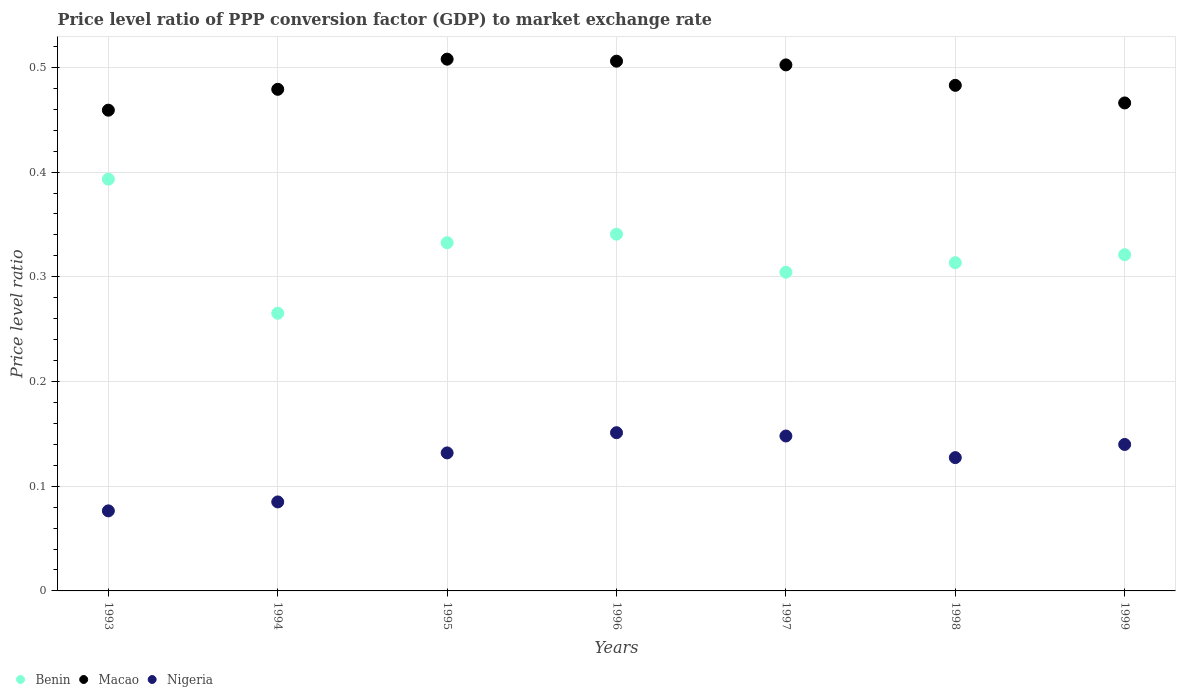What is the price level ratio in Macao in 1994?
Offer a terse response. 0.48. Across all years, what is the maximum price level ratio in Benin?
Ensure brevity in your answer.  0.39. Across all years, what is the minimum price level ratio in Benin?
Make the answer very short. 0.27. In which year was the price level ratio in Macao minimum?
Provide a short and direct response. 1993. What is the total price level ratio in Nigeria in the graph?
Offer a very short reply. 0.86. What is the difference between the price level ratio in Benin in 1996 and that in 1998?
Your response must be concise. 0.03. What is the difference between the price level ratio in Macao in 1993 and the price level ratio in Benin in 1994?
Offer a very short reply. 0.19. What is the average price level ratio in Nigeria per year?
Make the answer very short. 0.12. In the year 1995, what is the difference between the price level ratio in Macao and price level ratio in Benin?
Ensure brevity in your answer.  0.18. In how many years, is the price level ratio in Nigeria greater than 0.36000000000000004?
Give a very brief answer. 0. What is the ratio of the price level ratio in Nigeria in 1995 to that in 1997?
Offer a very short reply. 0.89. Is the price level ratio in Macao in 1993 less than that in 1998?
Give a very brief answer. Yes. What is the difference between the highest and the second highest price level ratio in Benin?
Your response must be concise. 0.05. What is the difference between the highest and the lowest price level ratio in Benin?
Make the answer very short. 0.13. Does the price level ratio in Benin monotonically increase over the years?
Keep it short and to the point. No. Is the price level ratio in Benin strictly greater than the price level ratio in Macao over the years?
Your answer should be very brief. No. How many dotlines are there?
Offer a very short reply. 3. How many legend labels are there?
Ensure brevity in your answer.  3. What is the title of the graph?
Ensure brevity in your answer.  Price level ratio of PPP conversion factor (GDP) to market exchange rate. Does "Mauritius" appear as one of the legend labels in the graph?
Your response must be concise. No. What is the label or title of the Y-axis?
Your answer should be compact. Price level ratio. What is the Price level ratio in Benin in 1993?
Ensure brevity in your answer.  0.39. What is the Price level ratio in Macao in 1993?
Offer a very short reply. 0.46. What is the Price level ratio of Nigeria in 1993?
Your answer should be very brief. 0.08. What is the Price level ratio of Benin in 1994?
Give a very brief answer. 0.27. What is the Price level ratio of Macao in 1994?
Your answer should be very brief. 0.48. What is the Price level ratio in Nigeria in 1994?
Your answer should be very brief. 0.08. What is the Price level ratio of Benin in 1995?
Provide a short and direct response. 0.33. What is the Price level ratio of Macao in 1995?
Provide a short and direct response. 0.51. What is the Price level ratio in Nigeria in 1995?
Your answer should be very brief. 0.13. What is the Price level ratio in Benin in 1996?
Make the answer very short. 0.34. What is the Price level ratio of Macao in 1996?
Provide a short and direct response. 0.51. What is the Price level ratio of Nigeria in 1996?
Make the answer very short. 0.15. What is the Price level ratio in Benin in 1997?
Keep it short and to the point. 0.3. What is the Price level ratio of Macao in 1997?
Provide a succinct answer. 0.5. What is the Price level ratio of Nigeria in 1997?
Provide a short and direct response. 0.15. What is the Price level ratio of Benin in 1998?
Provide a short and direct response. 0.31. What is the Price level ratio in Macao in 1998?
Offer a very short reply. 0.48. What is the Price level ratio of Nigeria in 1998?
Provide a succinct answer. 0.13. What is the Price level ratio in Benin in 1999?
Provide a succinct answer. 0.32. What is the Price level ratio of Macao in 1999?
Offer a terse response. 0.47. What is the Price level ratio in Nigeria in 1999?
Make the answer very short. 0.14. Across all years, what is the maximum Price level ratio of Benin?
Your response must be concise. 0.39. Across all years, what is the maximum Price level ratio in Macao?
Offer a terse response. 0.51. Across all years, what is the maximum Price level ratio of Nigeria?
Give a very brief answer. 0.15. Across all years, what is the minimum Price level ratio of Benin?
Your answer should be compact. 0.27. Across all years, what is the minimum Price level ratio in Macao?
Offer a terse response. 0.46. Across all years, what is the minimum Price level ratio of Nigeria?
Provide a short and direct response. 0.08. What is the total Price level ratio of Benin in the graph?
Give a very brief answer. 2.27. What is the total Price level ratio of Macao in the graph?
Your answer should be compact. 3.4. What is the total Price level ratio in Nigeria in the graph?
Your answer should be compact. 0.86. What is the difference between the Price level ratio of Benin in 1993 and that in 1994?
Your answer should be very brief. 0.13. What is the difference between the Price level ratio in Macao in 1993 and that in 1994?
Your answer should be compact. -0.02. What is the difference between the Price level ratio in Nigeria in 1993 and that in 1994?
Keep it short and to the point. -0.01. What is the difference between the Price level ratio of Benin in 1993 and that in 1995?
Make the answer very short. 0.06. What is the difference between the Price level ratio in Macao in 1993 and that in 1995?
Your answer should be compact. -0.05. What is the difference between the Price level ratio of Nigeria in 1993 and that in 1995?
Ensure brevity in your answer.  -0.06. What is the difference between the Price level ratio in Benin in 1993 and that in 1996?
Give a very brief answer. 0.05. What is the difference between the Price level ratio in Macao in 1993 and that in 1996?
Ensure brevity in your answer.  -0.05. What is the difference between the Price level ratio in Nigeria in 1993 and that in 1996?
Provide a short and direct response. -0.07. What is the difference between the Price level ratio in Benin in 1993 and that in 1997?
Your answer should be compact. 0.09. What is the difference between the Price level ratio in Macao in 1993 and that in 1997?
Ensure brevity in your answer.  -0.04. What is the difference between the Price level ratio of Nigeria in 1993 and that in 1997?
Your answer should be very brief. -0.07. What is the difference between the Price level ratio in Benin in 1993 and that in 1998?
Provide a short and direct response. 0.08. What is the difference between the Price level ratio of Macao in 1993 and that in 1998?
Your response must be concise. -0.02. What is the difference between the Price level ratio in Nigeria in 1993 and that in 1998?
Offer a terse response. -0.05. What is the difference between the Price level ratio in Benin in 1993 and that in 1999?
Your response must be concise. 0.07. What is the difference between the Price level ratio in Macao in 1993 and that in 1999?
Your answer should be very brief. -0.01. What is the difference between the Price level ratio in Nigeria in 1993 and that in 1999?
Make the answer very short. -0.06. What is the difference between the Price level ratio of Benin in 1994 and that in 1995?
Provide a short and direct response. -0.07. What is the difference between the Price level ratio of Macao in 1994 and that in 1995?
Offer a very short reply. -0.03. What is the difference between the Price level ratio of Nigeria in 1994 and that in 1995?
Offer a very short reply. -0.05. What is the difference between the Price level ratio of Benin in 1994 and that in 1996?
Provide a short and direct response. -0.08. What is the difference between the Price level ratio of Macao in 1994 and that in 1996?
Ensure brevity in your answer.  -0.03. What is the difference between the Price level ratio in Nigeria in 1994 and that in 1996?
Make the answer very short. -0.07. What is the difference between the Price level ratio of Benin in 1994 and that in 1997?
Your response must be concise. -0.04. What is the difference between the Price level ratio of Macao in 1994 and that in 1997?
Ensure brevity in your answer.  -0.02. What is the difference between the Price level ratio in Nigeria in 1994 and that in 1997?
Give a very brief answer. -0.06. What is the difference between the Price level ratio in Benin in 1994 and that in 1998?
Provide a succinct answer. -0.05. What is the difference between the Price level ratio in Macao in 1994 and that in 1998?
Your answer should be very brief. -0. What is the difference between the Price level ratio in Nigeria in 1994 and that in 1998?
Your response must be concise. -0.04. What is the difference between the Price level ratio of Benin in 1994 and that in 1999?
Offer a terse response. -0.06. What is the difference between the Price level ratio in Macao in 1994 and that in 1999?
Your response must be concise. 0.01. What is the difference between the Price level ratio of Nigeria in 1994 and that in 1999?
Offer a very short reply. -0.05. What is the difference between the Price level ratio in Benin in 1995 and that in 1996?
Your answer should be very brief. -0.01. What is the difference between the Price level ratio in Macao in 1995 and that in 1996?
Make the answer very short. 0. What is the difference between the Price level ratio in Nigeria in 1995 and that in 1996?
Your answer should be very brief. -0.02. What is the difference between the Price level ratio of Benin in 1995 and that in 1997?
Provide a succinct answer. 0.03. What is the difference between the Price level ratio of Macao in 1995 and that in 1997?
Provide a succinct answer. 0.01. What is the difference between the Price level ratio of Nigeria in 1995 and that in 1997?
Make the answer very short. -0.02. What is the difference between the Price level ratio in Benin in 1995 and that in 1998?
Provide a succinct answer. 0.02. What is the difference between the Price level ratio of Macao in 1995 and that in 1998?
Ensure brevity in your answer.  0.03. What is the difference between the Price level ratio in Nigeria in 1995 and that in 1998?
Provide a short and direct response. 0. What is the difference between the Price level ratio in Benin in 1995 and that in 1999?
Provide a short and direct response. 0.01. What is the difference between the Price level ratio in Macao in 1995 and that in 1999?
Ensure brevity in your answer.  0.04. What is the difference between the Price level ratio in Nigeria in 1995 and that in 1999?
Provide a succinct answer. -0.01. What is the difference between the Price level ratio of Benin in 1996 and that in 1997?
Your answer should be compact. 0.04. What is the difference between the Price level ratio in Macao in 1996 and that in 1997?
Keep it short and to the point. 0. What is the difference between the Price level ratio in Nigeria in 1996 and that in 1997?
Your answer should be very brief. 0. What is the difference between the Price level ratio of Benin in 1996 and that in 1998?
Offer a terse response. 0.03. What is the difference between the Price level ratio of Macao in 1996 and that in 1998?
Provide a succinct answer. 0.02. What is the difference between the Price level ratio in Nigeria in 1996 and that in 1998?
Provide a succinct answer. 0.02. What is the difference between the Price level ratio of Benin in 1996 and that in 1999?
Make the answer very short. 0.02. What is the difference between the Price level ratio of Macao in 1996 and that in 1999?
Make the answer very short. 0.04. What is the difference between the Price level ratio of Nigeria in 1996 and that in 1999?
Your answer should be compact. 0.01. What is the difference between the Price level ratio in Benin in 1997 and that in 1998?
Offer a terse response. -0.01. What is the difference between the Price level ratio of Macao in 1997 and that in 1998?
Make the answer very short. 0.02. What is the difference between the Price level ratio in Nigeria in 1997 and that in 1998?
Offer a terse response. 0.02. What is the difference between the Price level ratio in Benin in 1997 and that in 1999?
Your answer should be very brief. -0.02. What is the difference between the Price level ratio of Macao in 1997 and that in 1999?
Offer a very short reply. 0.04. What is the difference between the Price level ratio of Nigeria in 1997 and that in 1999?
Provide a short and direct response. 0.01. What is the difference between the Price level ratio in Benin in 1998 and that in 1999?
Provide a succinct answer. -0.01. What is the difference between the Price level ratio of Macao in 1998 and that in 1999?
Offer a very short reply. 0.02. What is the difference between the Price level ratio in Nigeria in 1998 and that in 1999?
Ensure brevity in your answer.  -0.01. What is the difference between the Price level ratio of Benin in 1993 and the Price level ratio of Macao in 1994?
Keep it short and to the point. -0.09. What is the difference between the Price level ratio in Benin in 1993 and the Price level ratio in Nigeria in 1994?
Your answer should be compact. 0.31. What is the difference between the Price level ratio of Macao in 1993 and the Price level ratio of Nigeria in 1994?
Make the answer very short. 0.37. What is the difference between the Price level ratio in Benin in 1993 and the Price level ratio in Macao in 1995?
Keep it short and to the point. -0.11. What is the difference between the Price level ratio in Benin in 1993 and the Price level ratio in Nigeria in 1995?
Provide a short and direct response. 0.26. What is the difference between the Price level ratio of Macao in 1993 and the Price level ratio of Nigeria in 1995?
Your answer should be very brief. 0.33. What is the difference between the Price level ratio of Benin in 1993 and the Price level ratio of Macao in 1996?
Ensure brevity in your answer.  -0.11. What is the difference between the Price level ratio of Benin in 1993 and the Price level ratio of Nigeria in 1996?
Make the answer very short. 0.24. What is the difference between the Price level ratio in Macao in 1993 and the Price level ratio in Nigeria in 1996?
Provide a short and direct response. 0.31. What is the difference between the Price level ratio in Benin in 1993 and the Price level ratio in Macao in 1997?
Your answer should be compact. -0.11. What is the difference between the Price level ratio in Benin in 1993 and the Price level ratio in Nigeria in 1997?
Your answer should be very brief. 0.25. What is the difference between the Price level ratio of Macao in 1993 and the Price level ratio of Nigeria in 1997?
Keep it short and to the point. 0.31. What is the difference between the Price level ratio of Benin in 1993 and the Price level ratio of Macao in 1998?
Offer a very short reply. -0.09. What is the difference between the Price level ratio in Benin in 1993 and the Price level ratio in Nigeria in 1998?
Offer a terse response. 0.27. What is the difference between the Price level ratio of Macao in 1993 and the Price level ratio of Nigeria in 1998?
Give a very brief answer. 0.33. What is the difference between the Price level ratio of Benin in 1993 and the Price level ratio of Macao in 1999?
Provide a succinct answer. -0.07. What is the difference between the Price level ratio of Benin in 1993 and the Price level ratio of Nigeria in 1999?
Provide a succinct answer. 0.25. What is the difference between the Price level ratio in Macao in 1993 and the Price level ratio in Nigeria in 1999?
Your answer should be compact. 0.32. What is the difference between the Price level ratio of Benin in 1994 and the Price level ratio of Macao in 1995?
Make the answer very short. -0.24. What is the difference between the Price level ratio of Benin in 1994 and the Price level ratio of Nigeria in 1995?
Offer a terse response. 0.13. What is the difference between the Price level ratio in Macao in 1994 and the Price level ratio in Nigeria in 1995?
Offer a very short reply. 0.35. What is the difference between the Price level ratio in Benin in 1994 and the Price level ratio in Macao in 1996?
Your answer should be very brief. -0.24. What is the difference between the Price level ratio in Benin in 1994 and the Price level ratio in Nigeria in 1996?
Keep it short and to the point. 0.11. What is the difference between the Price level ratio of Macao in 1994 and the Price level ratio of Nigeria in 1996?
Provide a short and direct response. 0.33. What is the difference between the Price level ratio of Benin in 1994 and the Price level ratio of Macao in 1997?
Offer a terse response. -0.24. What is the difference between the Price level ratio of Benin in 1994 and the Price level ratio of Nigeria in 1997?
Provide a succinct answer. 0.12. What is the difference between the Price level ratio of Macao in 1994 and the Price level ratio of Nigeria in 1997?
Offer a very short reply. 0.33. What is the difference between the Price level ratio of Benin in 1994 and the Price level ratio of Macao in 1998?
Your answer should be compact. -0.22. What is the difference between the Price level ratio in Benin in 1994 and the Price level ratio in Nigeria in 1998?
Keep it short and to the point. 0.14. What is the difference between the Price level ratio of Macao in 1994 and the Price level ratio of Nigeria in 1998?
Keep it short and to the point. 0.35. What is the difference between the Price level ratio of Benin in 1994 and the Price level ratio of Macao in 1999?
Provide a succinct answer. -0.2. What is the difference between the Price level ratio of Benin in 1994 and the Price level ratio of Nigeria in 1999?
Your answer should be compact. 0.13. What is the difference between the Price level ratio of Macao in 1994 and the Price level ratio of Nigeria in 1999?
Offer a very short reply. 0.34. What is the difference between the Price level ratio of Benin in 1995 and the Price level ratio of Macao in 1996?
Offer a very short reply. -0.17. What is the difference between the Price level ratio in Benin in 1995 and the Price level ratio in Nigeria in 1996?
Your answer should be very brief. 0.18. What is the difference between the Price level ratio in Macao in 1995 and the Price level ratio in Nigeria in 1996?
Ensure brevity in your answer.  0.36. What is the difference between the Price level ratio in Benin in 1995 and the Price level ratio in Macao in 1997?
Keep it short and to the point. -0.17. What is the difference between the Price level ratio in Benin in 1995 and the Price level ratio in Nigeria in 1997?
Give a very brief answer. 0.18. What is the difference between the Price level ratio in Macao in 1995 and the Price level ratio in Nigeria in 1997?
Make the answer very short. 0.36. What is the difference between the Price level ratio in Benin in 1995 and the Price level ratio in Macao in 1998?
Keep it short and to the point. -0.15. What is the difference between the Price level ratio of Benin in 1995 and the Price level ratio of Nigeria in 1998?
Give a very brief answer. 0.21. What is the difference between the Price level ratio in Macao in 1995 and the Price level ratio in Nigeria in 1998?
Ensure brevity in your answer.  0.38. What is the difference between the Price level ratio of Benin in 1995 and the Price level ratio of Macao in 1999?
Offer a terse response. -0.13. What is the difference between the Price level ratio of Benin in 1995 and the Price level ratio of Nigeria in 1999?
Offer a terse response. 0.19. What is the difference between the Price level ratio of Macao in 1995 and the Price level ratio of Nigeria in 1999?
Your answer should be compact. 0.37. What is the difference between the Price level ratio in Benin in 1996 and the Price level ratio in Macao in 1997?
Give a very brief answer. -0.16. What is the difference between the Price level ratio of Benin in 1996 and the Price level ratio of Nigeria in 1997?
Your response must be concise. 0.19. What is the difference between the Price level ratio in Macao in 1996 and the Price level ratio in Nigeria in 1997?
Provide a short and direct response. 0.36. What is the difference between the Price level ratio of Benin in 1996 and the Price level ratio of Macao in 1998?
Your answer should be compact. -0.14. What is the difference between the Price level ratio of Benin in 1996 and the Price level ratio of Nigeria in 1998?
Ensure brevity in your answer.  0.21. What is the difference between the Price level ratio in Macao in 1996 and the Price level ratio in Nigeria in 1998?
Provide a succinct answer. 0.38. What is the difference between the Price level ratio of Benin in 1996 and the Price level ratio of Macao in 1999?
Make the answer very short. -0.13. What is the difference between the Price level ratio of Benin in 1996 and the Price level ratio of Nigeria in 1999?
Make the answer very short. 0.2. What is the difference between the Price level ratio of Macao in 1996 and the Price level ratio of Nigeria in 1999?
Offer a terse response. 0.37. What is the difference between the Price level ratio of Benin in 1997 and the Price level ratio of Macao in 1998?
Keep it short and to the point. -0.18. What is the difference between the Price level ratio of Benin in 1997 and the Price level ratio of Nigeria in 1998?
Your answer should be compact. 0.18. What is the difference between the Price level ratio of Macao in 1997 and the Price level ratio of Nigeria in 1998?
Provide a short and direct response. 0.38. What is the difference between the Price level ratio in Benin in 1997 and the Price level ratio in Macao in 1999?
Offer a very short reply. -0.16. What is the difference between the Price level ratio of Benin in 1997 and the Price level ratio of Nigeria in 1999?
Ensure brevity in your answer.  0.16. What is the difference between the Price level ratio in Macao in 1997 and the Price level ratio in Nigeria in 1999?
Give a very brief answer. 0.36. What is the difference between the Price level ratio of Benin in 1998 and the Price level ratio of Macao in 1999?
Ensure brevity in your answer.  -0.15. What is the difference between the Price level ratio of Benin in 1998 and the Price level ratio of Nigeria in 1999?
Ensure brevity in your answer.  0.17. What is the difference between the Price level ratio in Macao in 1998 and the Price level ratio in Nigeria in 1999?
Give a very brief answer. 0.34. What is the average Price level ratio in Benin per year?
Provide a succinct answer. 0.32. What is the average Price level ratio in Macao per year?
Provide a short and direct response. 0.49. What is the average Price level ratio of Nigeria per year?
Your answer should be very brief. 0.12. In the year 1993, what is the difference between the Price level ratio of Benin and Price level ratio of Macao?
Your answer should be compact. -0.07. In the year 1993, what is the difference between the Price level ratio of Benin and Price level ratio of Nigeria?
Your answer should be compact. 0.32. In the year 1993, what is the difference between the Price level ratio in Macao and Price level ratio in Nigeria?
Give a very brief answer. 0.38. In the year 1994, what is the difference between the Price level ratio in Benin and Price level ratio in Macao?
Offer a very short reply. -0.21. In the year 1994, what is the difference between the Price level ratio in Benin and Price level ratio in Nigeria?
Ensure brevity in your answer.  0.18. In the year 1994, what is the difference between the Price level ratio of Macao and Price level ratio of Nigeria?
Give a very brief answer. 0.39. In the year 1995, what is the difference between the Price level ratio in Benin and Price level ratio in Macao?
Offer a very short reply. -0.18. In the year 1995, what is the difference between the Price level ratio in Benin and Price level ratio in Nigeria?
Your answer should be compact. 0.2. In the year 1995, what is the difference between the Price level ratio of Macao and Price level ratio of Nigeria?
Offer a very short reply. 0.38. In the year 1996, what is the difference between the Price level ratio of Benin and Price level ratio of Macao?
Provide a succinct answer. -0.17. In the year 1996, what is the difference between the Price level ratio of Benin and Price level ratio of Nigeria?
Give a very brief answer. 0.19. In the year 1996, what is the difference between the Price level ratio in Macao and Price level ratio in Nigeria?
Keep it short and to the point. 0.35. In the year 1997, what is the difference between the Price level ratio of Benin and Price level ratio of Macao?
Offer a terse response. -0.2. In the year 1997, what is the difference between the Price level ratio of Benin and Price level ratio of Nigeria?
Make the answer very short. 0.16. In the year 1997, what is the difference between the Price level ratio of Macao and Price level ratio of Nigeria?
Offer a terse response. 0.35. In the year 1998, what is the difference between the Price level ratio of Benin and Price level ratio of Macao?
Ensure brevity in your answer.  -0.17. In the year 1998, what is the difference between the Price level ratio of Benin and Price level ratio of Nigeria?
Provide a short and direct response. 0.19. In the year 1998, what is the difference between the Price level ratio of Macao and Price level ratio of Nigeria?
Ensure brevity in your answer.  0.36. In the year 1999, what is the difference between the Price level ratio of Benin and Price level ratio of Macao?
Your answer should be compact. -0.14. In the year 1999, what is the difference between the Price level ratio in Benin and Price level ratio in Nigeria?
Offer a very short reply. 0.18. In the year 1999, what is the difference between the Price level ratio of Macao and Price level ratio of Nigeria?
Your response must be concise. 0.33. What is the ratio of the Price level ratio in Benin in 1993 to that in 1994?
Ensure brevity in your answer.  1.48. What is the ratio of the Price level ratio in Macao in 1993 to that in 1994?
Ensure brevity in your answer.  0.96. What is the ratio of the Price level ratio of Nigeria in 1993 to that in 1994?
Ensure brevity in your answer.  0.9. What is the ratio of the Price level ratio of Benin in 1993 to that in 1995?
Your response must be concise. 1.18. What is the ratio of the Price level ratio of Macao in 1993 to that in 1995?
Your answer should be compact. 0.9. What is the ratio of the Price level ratio of Nigeria in 1993 to that in 1995?
Make the answer very short. 0.58. What is the ratio of the Price level ratio in Benin in 1993 to that in 1996?
Provide a succinct answer. 1.15. What is the ratio of the Price level ratio of Macao in 1993 to that in 1996?
Your answer should be very brief. 0.91. What is the ratio of the Price level ratio of Nigeria in 1993 to that in 1996?
Offer a very short reply. 0.51. What is the ratio of the Price level ratio of Benin in 1993 to that in 1997?
Offer a terse response. 1.29. What is the ratio of the Price level ratio of Macao in 1993 to that in 1997?
Offer a very short reply. 0.91. What is the ratio of the Price level ratio of Nigeria in 1993 to that in 1997?
Give a very brief answer. 0.52. What is the ratio of the Price level ratio of Benin in 1993 to that in 1998?
Your answer should be compact. 1.25. What is the ratio of the Price level ratio in Macao in 1993 to that in 1998?
Make the answer very short. 0.95. What is the ratio of the Price level ratio in Nigeria in 1993 to that in 1998?
Your response must be concise. 0.6. What is the ratio of the Price level ratio of Benin in 1993 to that in 1999?
Your answer should be very brief. 1.22. What is the ratio of the Price level ratio of Macao in 1993 to that in 1999?
Offer a terse response. 0.99. What is the ratio of the Price level ratio in Nigeria in 1993 to that in 1999?
Your answer should be very brief. 0.55. What is the ratio of the Price level ratio of Benin in 1994 to that in 1995?
Give a very brief answer. 0.8. What is the ratio of the Price level ratio in Macao in 1994 to that in 1995?
Your answer should be compact. 0.94. What is the ratio of the Price level ratio in Nigeria in 1994 to that in 1995?
Provide a short and direct response. 0.64. What is the ratio of the Price level ratio in Benin in 1994 to that in 1996?
Provide a short and direct response. 0.78. What is the ratio of the Price level ratio in Macao in 1994 to that in 1996?
Provide a short and direct response. 0.95. What is the ratio of the Price level ratio of Nigeria in 1994 to that in 1996?
Offer a terse response. 0.56. What is the ratio of the Price level ratio in Benin in 1994 to that in 1997?
Your answer should be compact. 0.87. What is the ratio of the Price level ratio in Macao in 1994 to that in 1997?
Provide a succinct answer. 0.95. What is the ratio of the Price level ratio in Nigeria in 1994 to that in 1997?
Ensure brevity in your answer.  0.57. What is the ratio of the Price level ratio of Benin in 1994 to that in 1998?
Provide a succinct answer. 0.85. What is the ratio of the Price level ratio in Macao in 1994 to that in 1998?
Ensure brevity in your answer.  0.99. What is the ratio of the Price level ratio in Nigeria in 1994 to that in 1998?
Offer a terse response. 0.67. What is the ratio of the Price level ratio in Benin in 1994 to that in 1999?
Your answer should be compact. 0.83. What is the ratio of the Price level ratio in Macao in 1994 to that in 1999?
Ensure brevity in your answer.  1.03. What is the ratio of the Price level ratio of Nigeria in 1994 to that in 1999?
Make the answer very short. 0.61. What is the ratio of the Price level ratio in Benin in 1995 to that in 1996?
Provide a short and direct response. 0.98. What is the ratio of the Price level ratio of Nigeria in 1995 to that in 1996?
Give a very brief answer. 0.87. What is the ratio of the Price level ratio of Benin in 1995 to that in 1997?
Keep it short and to the point. 1.09. What is the ratio of the Price level ratio in Macao in 1995 to that in 1997?
Offer a very short reply. 1.01. What is the ratio of the Price level ratio of Nigeria in 1995 to that in 1997?
Your answer should be very brief. 0.89. What is the ratio of the Price level ratio in Benin in 1995 to that in 1998?
Keep it short and to the point. 1.06. What is the ratio of the Price level ratio in Macao in 1995 to that in 1998?
Your answer should be very brief. 1.05. What is the ratio of the Price level ratio of Nigeria in 1995 to that in 1998?
Provide a short and direct response. 1.04. What is the ratio of the Price level ratio of Benin in 1995 to that in 1999?
Offer a terse response. 1.04. What is the ratio of the Price level ratio in Macao in 1995 to that in 1999?
Give a very brief answer. 1.09. What is the ratio of the Price level ratio of Nigeria in 1995 to that in 1999?
Offer a terse response. 0.94. What is the ratio of the Price level ratio in Benin in 1996 to that in 1997?
Provide a short and direct response. 1.12. What is the ratio of the Price level ratio in Macao in 1996 to that in 1997?
Ensure brevity in your answer.  1.01. What is the ratio of the Price level ratio in Nigeria in 1996 to that in 1997?
Offer a very short reply. 1.02. What is the ratio of the Price level ratio of Benin in 1996 to that in 1998?
Give a very brief answer. 1.09. What is the ratio of the Price level ratio in Macao in 1996 to that in 1998?
Provide a succinct answer. 1.05. What is the ratio of the Price level ratio of Nigeria in 1996 to that in 1998?
Make the answer very short. 1.19. What is the ratio of the Price level ratio of Benin in 1996 to that in 1999?
Ensure brevity in your answer.  1.06. What is the ratio of the Price level ratio of Macao in 1996 to that in 1999?
Provide a succinct answer. 1.09. What is the ratio of the Price level ratio of Nigeria in 1996 to that in 1999?
Your answer should be compact. 1.08. What is the ratio of the Price level ratio of Benin in 1997 to that in 1998?
Give a very brief answer. 0.97. What is the ratio of the Price level ratio in Macao in 1997 to that in 1998?
Your answer should be very brief. 1.04. What is the ratio of the Price level ratio of Nigeria in 1997 to that in 1998?
Your response must be concise. 1.16. What is the ratio of the Price level ratio of Benin in 1997 to that in 1999?
Your answer should be compact. 0.95. What is the ratio of the Price level ratio of Macao in 1997 to that in 1999?
Make the answer very short. 1.08. What is the ratio of the Price level ratio of Nigeria in 1997 to that in 1999?
Ensure brevity in your answer.  1.06. What is the ratio of the Price level ratio of Benin in 1998 to that in 1999?
Your answer should be very brief. 0.98. What is the ratio of the Price level ratio of Macao in 1998 to that in 1999?
Your response must be concise. 1.04. What is the ratio of the Price level ratio of Nigeria in 1998 to that in 1999?
Your answer should be compact. 0.91. What is the difference between the highest and the second highest Price level ratio in Benin?
Your response must be concise. 0.05. What is the difference between the highest and the second highest Price level ratio in Macao?
Provide a succinct answer. 0. What is the difference between the highest and the second highest Price level ratio of Nigeria?
Provide a succinct answer. 0. What is the difference between the highest and the lowest Price level ratio of Benin?
Keep it short and to the point. 0.13. What is the difference between the highest and the lowest Price level ratio in Macao?
Ensure brevity in your answer.  0.05. What is the difference between the highest and the lowest Price level ratio of Nigeria?
Provide a succinct answer. 0.07. 